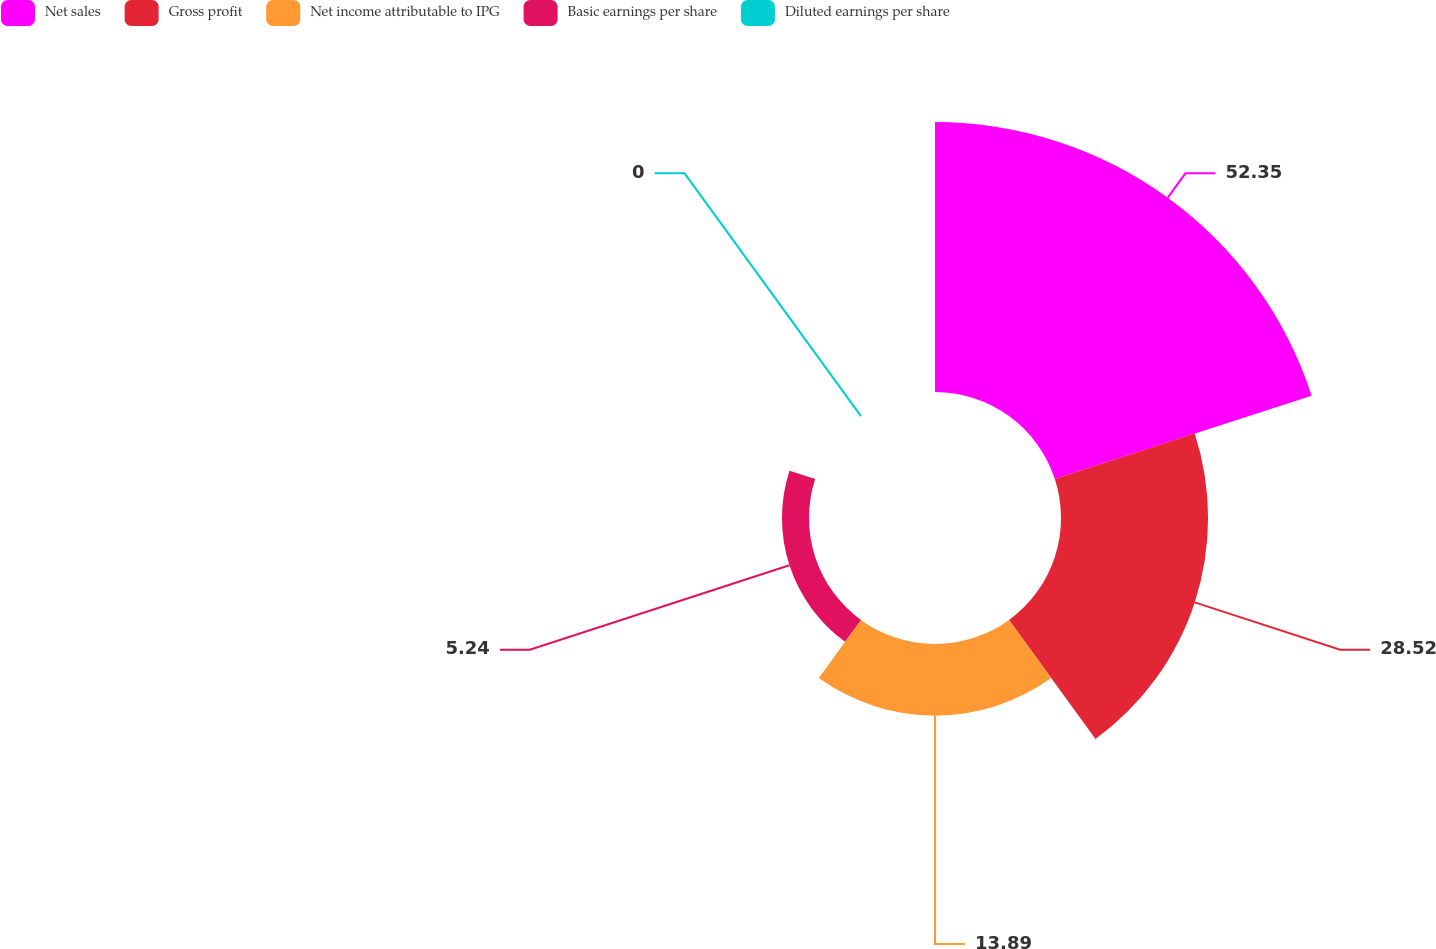Convert chart. <chart><loc_0><loc_0><loc_500><loc_500><pie_chart><fcel>Net sales<fcel>Gross profit<fcel>Net income attributable to IPG<fcel>Basic earnings per share<fcel>Diluted earnings per share<nl><fcel>52.36%<fcel>28.52%<fcel>13.89%<fcel>5.24%<fcel>0.0%<nl></chart> 